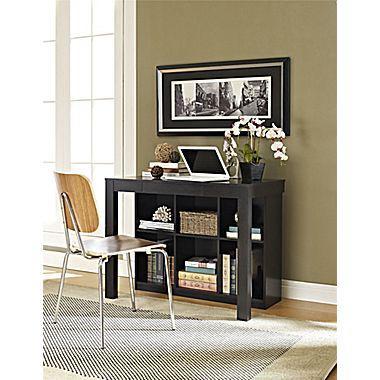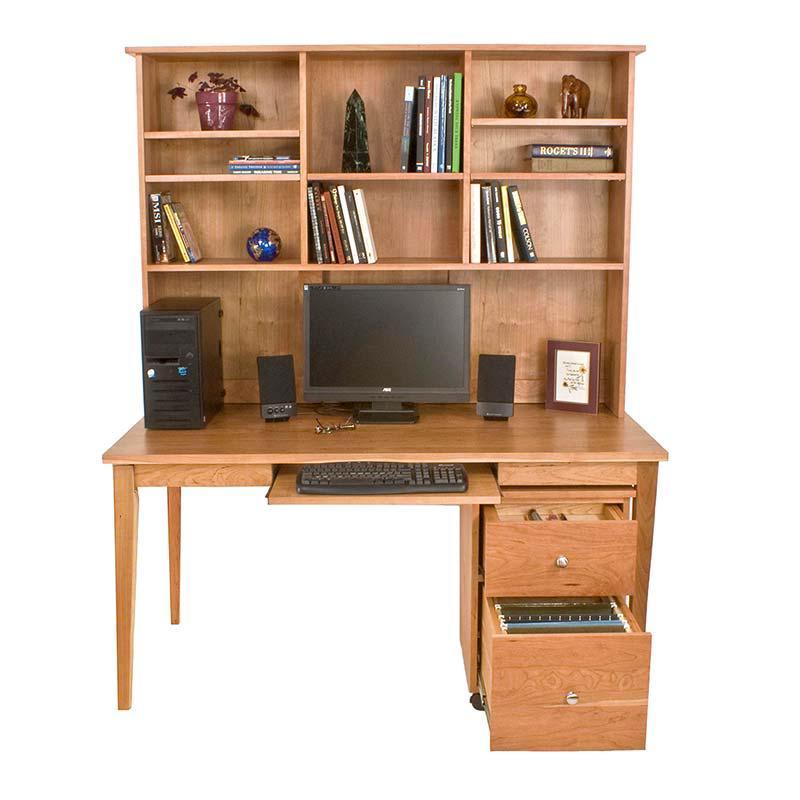The first image is the image on the left, the second image is the image on the right. Examine the images to the left and right. Is the description "There is a chair in front of one of the office units." accurate? Answer yes or no. Yes. The first image is the image on the left, the second image is the image on the right. Given the left and right images, does the statement "The laptop screen is angled away from the front." hold true? Answer yes or no. No. 